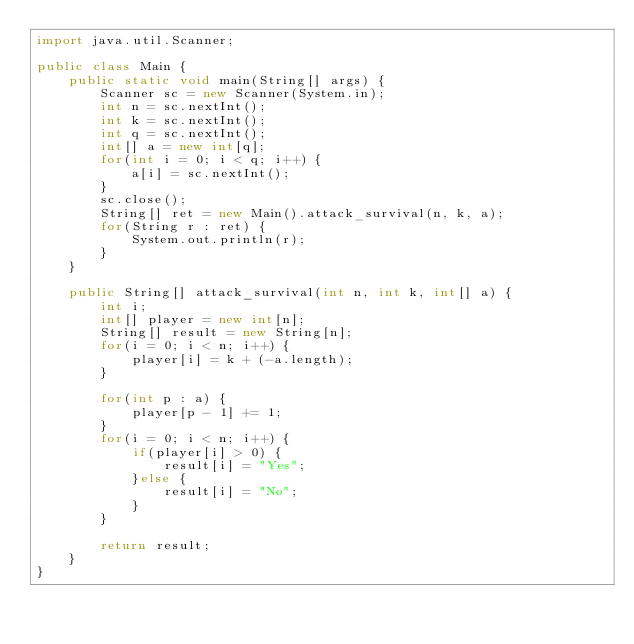<code> <loc_0><loc_0><loc_500><loc_500><_Java_>import java.util.Scanner;

public class Main {
	public static void main(String[] args) {
		Scanner sc = new Scanner(System.in);
		int n = sc.nextInt();
		int k = sc.nextInt();
		int q = sc.nextInt();
		int[] a = new int[q];
		for(int i = 0; i < q; i++) {
			a[i] = sc.nextInt();
		}
		sc.close();
		String[] ret = new Main().attack_survival(n, k, a);
		for(String r : ret) {
			System.out.println(r);
		}
	}
	
	public String[] attack_survival(int n, int k, int[] a) {
		int i;
		int[] player = new int[n];
		String[] result = new String[n];
		for(i = 0; i < n; i++) {
			player[i] = k + (-a.length);
		}
		
		for(int p : a) {
			player[p - 1] += 1;
		}
		for(i = 0; i < n; i++) {
			if(player[i] > 0) {
				result[i] = "Yes";
			}else {
				result[i] = "No";
			}
		}
		
		return result;
	}
}
</code> 